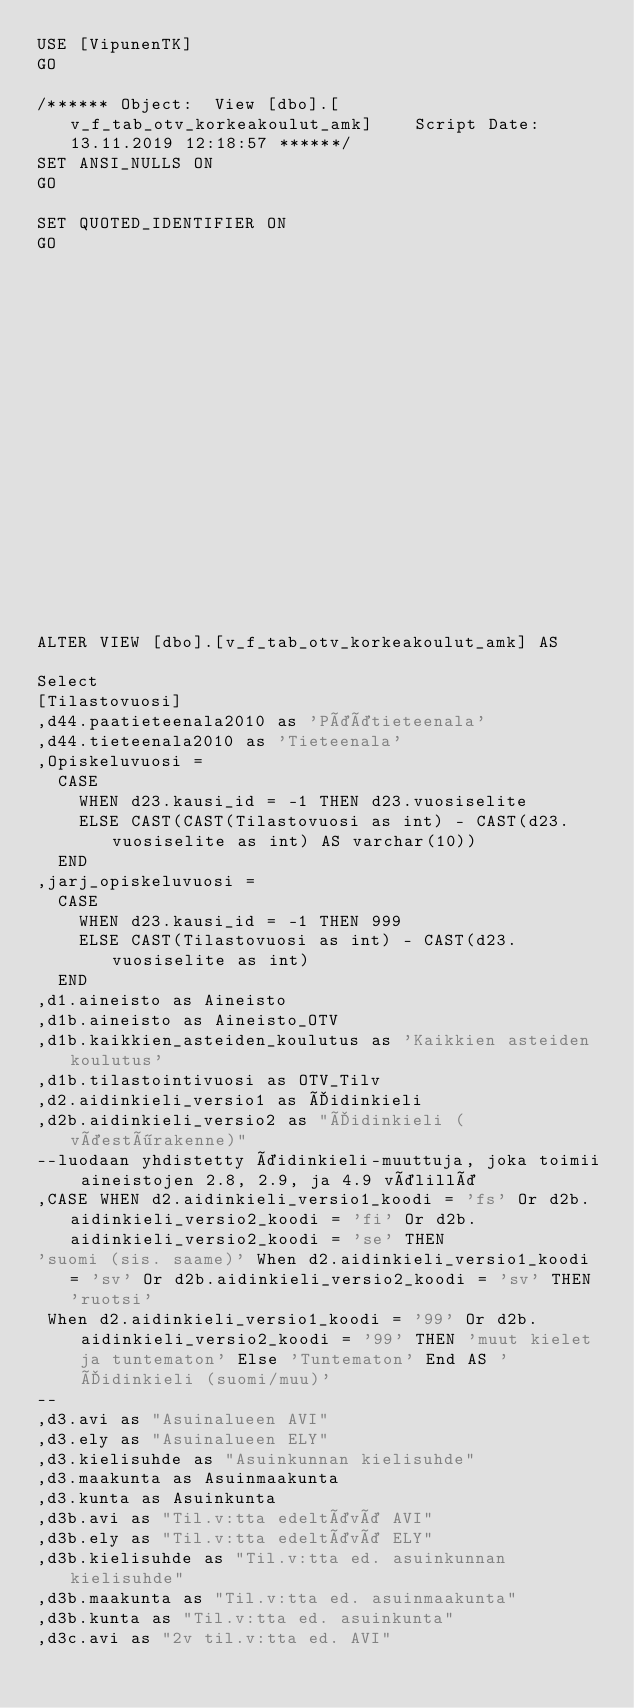<code> <loc_0><loc_0><loc_500><loc_500><_SQL_>USE [VipunenTK]
GO

/****** Object:  View [dbo].[v_f_tab_otv_korkeakoulut_amk]    Script Date: 13.11.2019 12:18:57 ******/
SET ANSI_NULLS ON
GO

SET QUOTED_IDENTIFIER ON
GO



















ALTER VIEW [dbo].[v_f_tab_otv_korkeakoulut_amk] AS

Select
[Tilastovuosi]
,d44.paatieteenala2010 as 'Päätieteenala'
,d44.tieteenala2010 as 'Tieteenala'
,Opiskeluvuosi = 
	CASE
		WHEN d23.kausi_id = -1 THEN d23.vuosiselite
		ELSE CAST(CAST(Tilastovuosi as int) - CAST(d23.vuosiselite as int) AS varchar(10))
	END
,jarj_opiskeluvuosi = 
	CASE
		WHEN d23.kausi_id = -1 THEN 999
		ELSE CAST(Tilastovuosi as int) - CAST(d23.vuosiselite as int)
	END
,d1.aineisto as Aineisto
,d1b.aineisto as Aineisto_OTV
,d1b.kaikkien_asteiden_koulutus as 'Kaikkien asteiden koulutus'
,d1b.tilastointivuosi as OTV_Tilv
,d2.aidinkieli_versio1 as Äidinkieli
,d2b.aidinkieli_versio2 as "Äidinkieli (väestörakenne)"
--luodaan yhdistetty äidinkieli-muuttuja, joka toimii aineistojen 2.8, 2.9, ja 4.9 välillä
,CASE WHEN d2.aidinkieli_versio1_koodi = 'fs' Or d2b.aidinkieli_versio2_koodi = 'fi' Or d2b.aidinkieli_versio2_koodi = 'se' THEN
'suomi (sis. saame)' When d2.aidinkieli_versio1_koodi = 'sv' Or d2b.aidinkieli_versio2_koodi = 'sv' THEN 'ruotsi'
 When d2.aidinkieli_versio1_koodi = '99' Or d2b.aidinkieli_versio2_koodi = '99' THEN 'muut kielet ja tuntematon' Else 'Tuntematon' End AS 'Äidinkieli (suomi/muu)'
--
,d3.avi as "Asuinalueen AVI"
,d3.ely as "Asuinalueen ELY"
,d3.kielisuhde as "Asuinkunnan kielisuhde"
,d3.maakunta as Asuinmaakunta
,d3.kunta as Asuinkunta
,d3b.avi as "Til.v:tta edeltävä AVI"
,d3b.ely as "Til.v:tta edeltävä ELY"
,d3b.kielisuhde as "Til.v:tta ed. asuinkunnan kielisuhde"
,d3b.maakunta as "Til.v:tta ed. asuinmaakunta"
,d3b.kunta as "Til.v:tta ed. asuinkunta"
,d3c.avi as "2v til.v:tta ed. AVI"</code> 